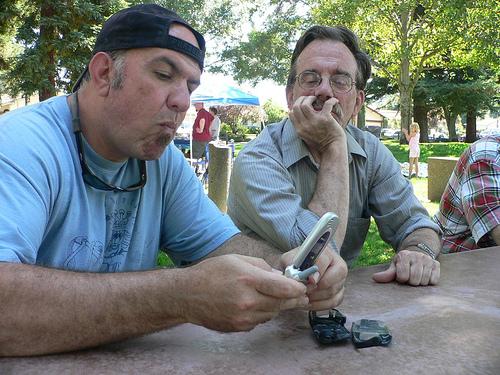Who is he calling?
Answer briefly. Friend. Are these men in a shady or sunny area of the park?
Concise answer only. Shady. What is the man wearing around his neck?
Be succinct. Sunglasses. 